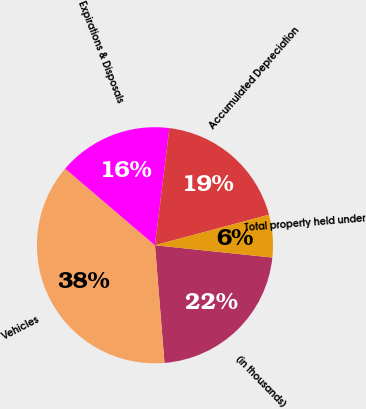<chart> <loc_0><loc_0><loc_500><loc_500><pie_chart><fcel>(in thousands)<fcel>Vehicles<fcel>Expirations & Disposals<fcel>Accumulated Depreciation<fcel>Total property held under<nl><fcel>22.05%<fcel>37.53%<fcel>15.71%<fcel>18.88%<fcel>5.83%<nl></chart> 